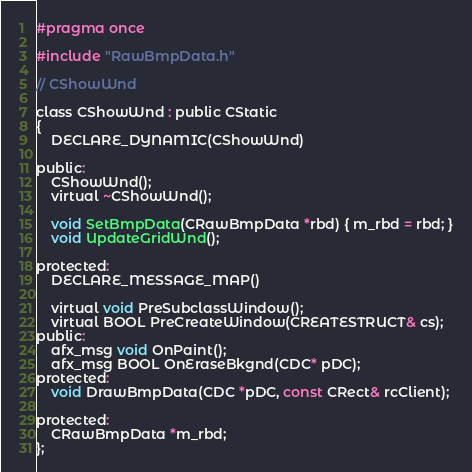Convert code to text. <code><loc_0><loc_0><loc_500><loc_500><_C_>#pragma once

#include "RawBmpData.h"

// CShowWnd

class CShowWnd : public CStatic
{
	DECLARE_DYNAMIC(CShowWnd)

public:
	CShowWnd();
	virtual ~CShowWnd();

    void SetBmpData(CRawBmpData *rbd) { m_rbd = rbd; }
    void UpdateGridWnd();

protected:
	DECLARE_MESSAGE_MAP()

    virtual void PreSubclassWindow();
    virtual BOOL PreCreateWindow(CREATESTRUCT& cs);
public:
    afx_msg void OnPaint();
    afx_msg BOOL OnEraseBkgnd(CDC* pDC);
protected:
    void DrawBmpData(CDC *pDC, const CRect& rcClient);

protected:
    CRawBmpData *m_rbd;
};



</code> 